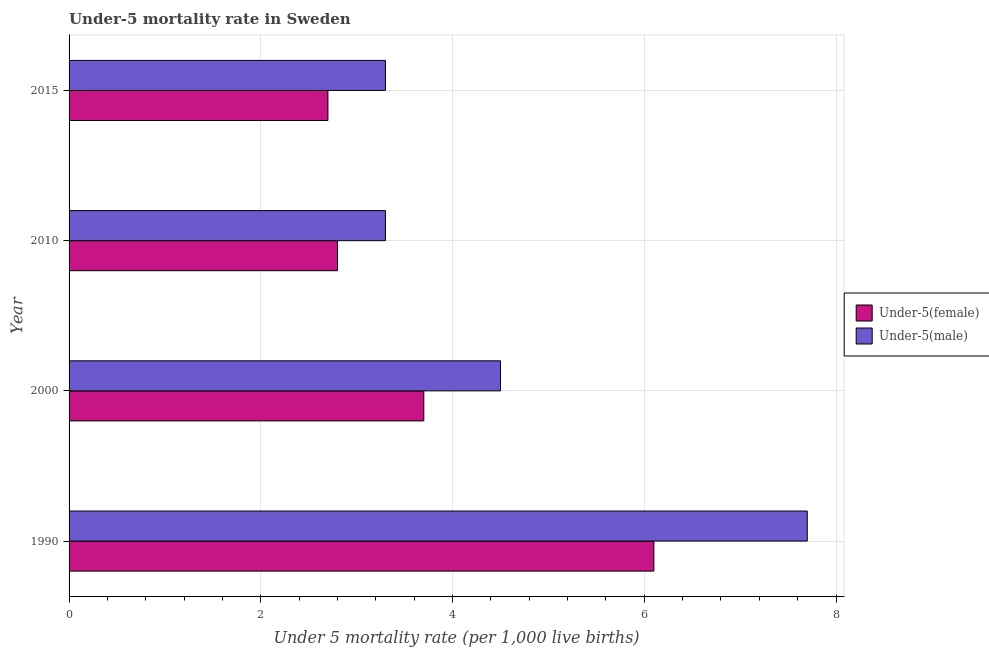How many different coloured bars are there?
Your response must be concise. 2. How many groups of bars are there?
Your answer should be compact. 4. Are the number of bars on each tick of the Y-axis equal?
Offer a very short reply. Yes. How many bars are there on the 4th tick from the top?
Your answer should be very brief. 2. What is the label of the 1st group of bars from the top?
Offer a very short reply. 2015. In how many cases, is the number of bars for a given year not equal to the number of legend labels?
Your response must be concise. 0. What is the under-5 female mortality rate in 2010?
Give a very brief answer. 2.8. In which year was the under-5 male mortality rate minimum?
Make the answer very short. 2010. What is the difference between the under-5 female mortality rate in 2000 and that in 2015?
Keep it short and to the point. 1. What is the difference between the under-5 female mortality rate in 2010 and the under-5 male mortality rate in 2000?
Ensure brevity in your answer.  -1.7. What is the average under-5 female mortality rate per year?
Offer a very short reply. 3.83. In the year 2000, what is the difference between the under-5 female mortality rate and under-5 male mortality rate?
Ensure brevity in your answer.  -0.8. In how many years, is the under-5 female mortality rate greater than 5.6 ?
Your answer should be very brief. 1. What is the ratio of the under-5 female mortality rate in 1990 to that in 2015?
Your answer should be compact. 2.26. What is the difference between the highest and the second highest under-5 male mortality rate?
Offer a terse response. 3.2. In how many years, is the under-5 female mortality rate greater than the average under-5 female mortality rate taken over all years?
Ensure brevity in your answer.  1. What does the 1st bar from the top in 2000 represents?
Provide a short and direct response. Under-5(male). What does the 1st bar from the bottom in 2015 represents?
Keep it short and to the point. Under-5(female). Are all the bars in the graph horizontal?
Make the answer very short. Yes. Does the graph contain any zero values?
Your answer should be compact. No. How are the legend labels stacked?
Your answer should be very brief. Vertical. What is the title of the graph?
Offer a terse response. Under-5 mortality rate in Sweden. Does "Girls" appear as one of the legend labels in the graph?
Offer a very short reply. No. What is the label or title of the X-axis?
Your response must be concise. Under 5 mortality rate (per 1,0 live births). What is the Under 5 mortality rate (per 1,000 live births) in Under-5(male) in 1990?
Keep it short and to the point. 7.7. What is the Under 5 mortality rate (per 1,000 live births) in Under-5(male) in 2000?
Your response must be concise. 4.5. What is the Under 5 mortality rate (per 1,000 live births) of Under-5(male) in 2015?
Your response must be concise. 3.3. Across all years, what is the maximum Under 5 mortality rate (per 1,000 live births) of Under-5(female)?
Your answer should be compact. 6.1. Across all years, what is the maximum Under 5 mortality rate (per 1,000 live births) in Under-5(male)?
Keep it short and to the point. 7.7. Across all years, what is the minimum Under 5 mortality rate (per 1,000 live births) of Under-5(male)?
Make the answer very short. 3.3. What is the total Under 5 mortality rate (per 1,000 live births) of Under-5(female) in the graph?
Your answer should be very brief. 15.3. What is the difference between the Under 5 mortality rate (per 1,000 live births) of Under-5(female) in 1990 and that in 2000?
Keep it short and to the point. 2.4. What is the difference between the Under 5 mortality rate (per 1,000 live births) of Under-5(male) in 1990 and that in 2000?
Make the answer very short. 3.2. What is the difference between the Under 5 mortality rate (per 1,000 live births) in Under-5(female) in 1990 and that in 2010?
Offer a terse response. 3.3. What is the difference between the Under 5 mortality rate (per 1,000 live births) in Under-5(female) in 1990 and that in 2015?
Offer a very short reply. 3.4. What is the difference between the Under 5 mortality rate (per 1,000 live births) of Under-5(female) in 2000 and that in 2010?
Make the answer very short. 0.9. What is the difference between the Under 5 mortality rate (per 1,000 live births) of Under-5(female) in 2010 and that in 2015?
Keep it short and to the point. 0.1. What is the difference between the Under 5 mortality rate (per 1,000 live births) of Under-5(male) in 2010 and that in 2015?
Your answer should be very brief. 0. What is the difference between the Under 5 mortality rate (per 1,000 live births) of Under-5(female) in 1990 and the Under 5 mortality rate (per 1,000 live births) of Under-5(male) in 2000?
Keep it short and to the point. 1.6. What is the difference between the Under 5 mortality rate (per 1,000 live births) in Under-5(female) in 1990 and the Under 5 mortality rate (per 1,000 live births) in Under-5(male) in 2015?
Make the answer very short. 2.8. What is the difference between the Under 5 mortality rate (per 1,000 live births) in Under-5(female) in 2000 and the Under 5 mortality rate (per 1,000 live births) in Under-5(male) in 2010?
Give a very brief answer. 0.4. What is the difference between the Under 5 mortality rate (per 1,000 live births) in Under-5(female) in 2000 and the Under 5 mortality rate (per 1,000 live births) in Under-5(male) in 2015?
Your response must be concise. 0.4. What is the average Under 5 mortality rate (per 1,000 live births) of Under-5(female) per year?
Ensure brevity in your answer.  3.83. What is the average Under 5 mortality rate (per 1,000 live births) of Under-5(male) per year?
Offer a very short reply. 4.7. In the year 1990, what is the difference between the Under 5 mortality rate (per 1,000 live births) in Under-5(female) and Under 5 mortality rate (per 1,000 live births) in Under-5(male)?
Offer a very short reply. -1.6. In the year 2015, what is the difference between the Under 5 mortality rate (per 1,000 live births) of Under-5(female) and Under 5 mortality rate (per 1,000 live births) of Under-5(male)?
Your response must be concise. -0.6. What is the ratio of the Under 5 mortality rate (per 1,000 live births) of Under-5(female) in 1990 to that in 2000?
Give a very brief answer. 1.65. What is the ratio of the Under 5 mortality rate (per 1,000 live births) of Under-5(male) in 1990 to that in 2000?
Give a very brief answer. 1.71. What is the ratio of the Under 5 mortality rate (per 1,000 live births) in Under-5(female) in 1990 to that in 2010?
Provide a succinct answer. 2.18. What is the ratio of the Under 5 mortality rate (per 1,000 live births) of Under-5(male) in 1990 to that in 2010?
Ensure brevity in your answer.  2.33. What is the ratio of the Under 5 mortality rate (per 1,000 live births) in Under-5(female) in 1990 to that in 2015?
Give a very brief answer. 2.26. What is the ratio of the Under 5 mortality rate (per 1,000 live births) in Under-5(male) in 1990 to that in 2015?
Provide a succinct answer. 2.33. What is the ratio of the Under 5 mortality rate (per 1,000 live births) in Under-5(female) in 2000 to that in 2010?
Provide a succinct answer. 1.32. What is the ratio of the Under 5 mortality rate (per 1,000 live births) of Under-5(male) in 2000 to that in 2010?
Ensure brevity in your answer.  1.36. What is the ratio of the Under 5 mortality rate (per 1,000 live births) of Under-5(female) in 2000 to that in 2015?
Your answer should be compact. 1.37. What is the ratio of the Under 5 mortality rate (per 1,000 live births) in Under-5(male) in 2000 to that in 2015?
Your response must be concise. 1.36. What is the difference between the highest and the second highest Under 5 mortality rate (per 1,000 live births) in Under-5(female)?
Offer a very short reply. 2.4. What is the difference between the highest and the lowest Under 5 mortality rate (per 1,000 live births) of Under-5(female)?
Offer a very short reply. 3.4. What is the difference between the highest and the lowest Under 5 mortality rate (per 1,000 live births) of Under-5(male)?
Your answer should be very brief. 4.4. 